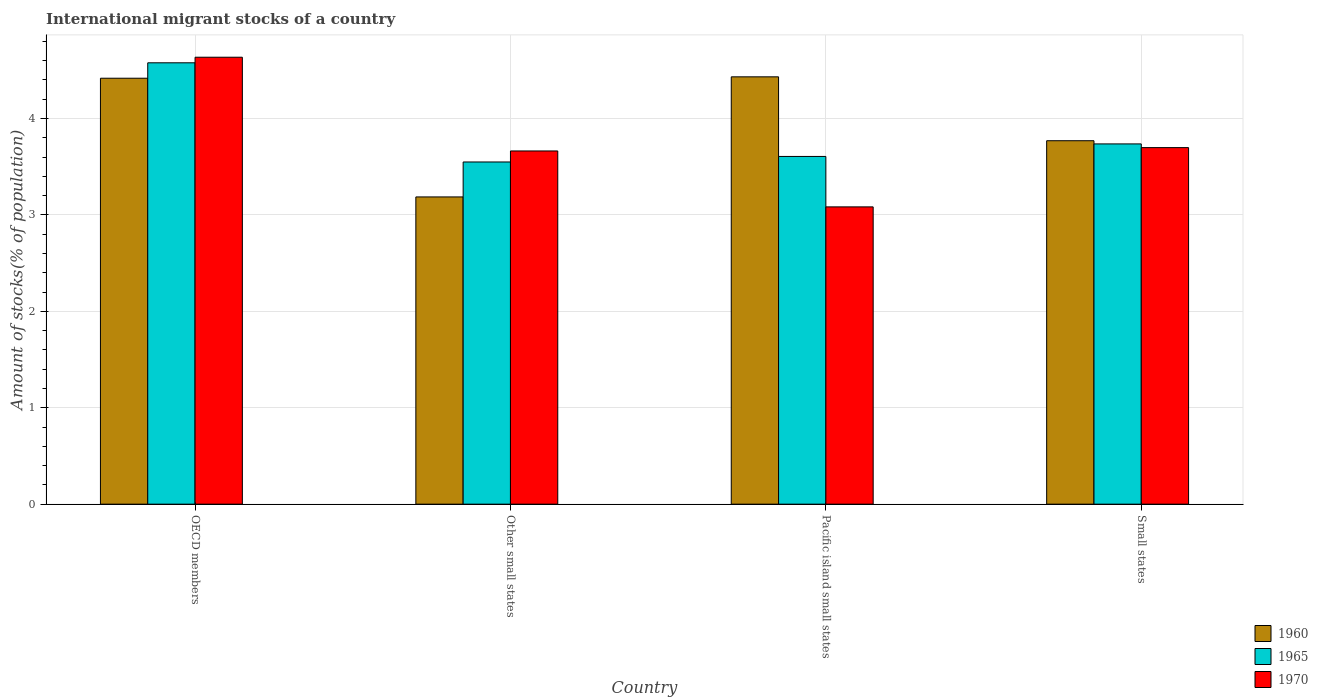Are the number of bars per tick equal to the number of legend labels?
Provide a succinct answer. Yes. Are the number of bars on each tick of the X-axis equal?
Offer a very short reply. Yes. In how many cases, is the number of bars for a given country not equal to the number of legend labels?
Provide a short and direct response. 0. What is the amount of stocks in in 1970 in Small states?
Make the answer very short. 3.7. Across all countries, what is the maximum amount of stocks in in 1965?
Give a very brief answer. 4.58. Across all countries, what is the minimum amount of stocks in in 1965?
Your answer should be very brief. 3.55. In which country was the amount of stocks in in 1960 minimum?
Ensure brevity in your answer.  Other small states. What is the total amount of stocks in in 1965 in the graph?
Give a very brief answer. 15.47. What is the difference between the amount of stocks in in 1970 in OECD members and that in Small states?
Give a very brief answer. 0.94. What is the difference between the amount of stocks in in 1970 in Small states and the amount of stocks in in 1965 in Other small states?
Ensure brevity in your answer.  0.15. What is the average amount of stocks in in 1960 per country?
Provide a short and direct response. 3.95. What is the difference between the amount of stocks in of/in 1965 and amount of stocks in of/in 1960 in Small states?
Ensure brevity in your answer.  -0.03. What is the ratio of the amount of stocks in in 1970 in Other small states to that in Pacific island small states?
Offer a terse response. 1.19. Is the amount of stocks in in 1970 in Other small states less than that in Pacific island small states?
Ensure brevity in your answer.  No. Is the difference between the amount of stocks in in 1965 in Other small states and Small states greater than the difference between the amount of stocks in in 1960 in Other small states and Small states?
Your answer should be compact. Yes. What is the difference between the highest and the second highest amount of stocks in in 1970?
Make the answer very short. -0.03. What is the difference between the highest and the lowest amount of stocks in in 1965?
Your answer should be very brief. 1.03. What does the 2nd bar from the left in Small states represents?
Give a very brief answer. 1965. What does the 1st bar from the right in Small states represents?
Offer a terse response. 1970. Is it the case that in every country, the sum of the amount of stocks in in 1960 and amount of stocks in in 1970 is greater than the amount of stocks in in 1965?
Provide a succinct answer. Yes. How many bars are there?
Make the answer very short. 12. Are all the bars in the graph horizontal?
Offer a terse response. No. How many countries are there in the graph?
Provide a short and direct response. 4. Does the graph contain any zero values?
Ensure brevity in your answer.  No. Does the graph contain grids?
Keep it short and to the point. Yes. Where does the legend appear in the graph?
Your answer should be very brief. Bottom right. How many legend labels are there?
Provide a succinct answer. 3. How are the legend labels stacked?
Ensure brevity in your answer.  Vertical. What is the title of the graph?
Offer a very short reply. International migrant stocks of a country. Does "1999" appear as one of the legend labels in the graph?
Offer a very short reply. No. What is the label or title of the Y-axis?
Offer a terse response. Amount of stocks(% of population). What is the Amount of stocks(% of population) in 1960 in OECD members?
Provide a short and direct response. 4.42. What is the Amount of stocks(% of population) of 1965 in OECD members?
Make the answer very short. 4.58. What is the Amount of stocks(% of population) of 1970 in OECD members?
Ensure brevity in your answer.  4.63. What is the Amount of stocks(% of population) in 1960 in Other small states?
Your response must be concise. 3.19. What is the Amount of stocks(% of population) in 1965 in Other small states?
Provide a short and direct response. 3.55. What is the Amount of stocks(% of population) of 1970 in Other small states?
Offer a very short reply. 3.66. What is the Amount of stocks(% of population) of 1960 in Pacific island small states?
Offer a terse response. 4.43. What is the Amount of stocks(% of population) of 1965 in Pacific island small states?
Ensure brevity in your answer.  3.61. What is the Amount of stocks(% of population) of 1970 in Pacific island small states?
Ensure brevity in your answer.  3.08. What is the Amount of stocks(% of population) in 1960 in Small states?
Your response must be concise. 3.77. What is the Amount of stocks(% of population) in 1965 in Small states?
Make the answer very short. 3.74. What is the Amount of stocks(% of population) of 1970 in Small states?
Make the answer very short. 3.7. Across all countries, what is the maximum Amount of stocks(% of population) in 1960?
Offer a very short reply. 4.43. Across all countries, what is the maximum Amount of stocks(% of population) in 1965?
Provide a short and direct response. 4.58. Across all countries, what is the maximum Amount of stocks(% of population) in 1970?
Offer a terse response. 4.63. Across all countries, what is the minimum Amount of stocks(% of population) of 1960?
Provide a short and direct response. 3.19. Across all countries, what is the minimum Amount of stocks(% of population) of 1965?
Provide a short and direct response. 3.55. Across all countries, what is the minimum Amount of stocks(% of population) in 1970?
Your answer should be compact. 3.08. What is the total Amount of stocks(% of population) in 1960 in the graph?
Your answer should be compact. 15.8. What is the total Amount of stocks(% of population) in 1965 in the graph?
Make the answer very short. 15.47. What is the total Amount of stocks(% of population) in 1970 in the graph?
Provide a short and direct response. 15.08. What is the difference between the Amount of stocks(% of population) of 1960 in OECD members and that in Other small states?
Offer a very short reply. 1.23. What is the difference between the Amount of stocks(% of population) of 1965 in OECD members and that in Other small states?
Your answer should be compact. 1.03. What is the difference between the Amount of stocks(% of population) of 1970 in OECD members and that in Other small states?
Keep it short and to the point. 0.97. What is the difference between the Amount of stocks(% of population) in 1960 in OECD members and that in Pacific island small states?
Give a very brief answer. -0.01. What is the difference between the Amount of stocks(% of population) in 1970 in OECD members and that in Pacific island small states?
Your answer should be compact. 1.55. What is the difference between the Amount of stocks(% of population) of 1960 in OECD members and that in Small states?
Your answer should be compact. 0.65. What is the difference between the Amount of stocks(% of population) of 1965 in OECD members and that in Small states?
Your response must be concise. 0.84. What is the difference between the Amount of stocks(% of population) in 1970 in OECD members and that in Small states?
Keep it short and to the point. 0.94. What is the difference between the Amount of stocks(% of population) in 1960 in Other small states and that in Pacific island small states?
Ensure brevity in your answer.  -1.25. What is the difference between the Amount of stocks(% of population) in 1965 in Other small states and that in Pacific island small states?
Ensure brevity in your answer.  -0.06. What is the difference between the Amount of stocks(% of population) in 1970 in Other small states and that in Pacific island small states?
Your response must be concise. 0.58. What is the difference between the Amount of stocks(% of population) of 1960 in Other small states and that in Small states?
Offer a very short reply. -0.58. What is the difference between the Amount of stocks(% of population) in 1965 in Other small states and that in Small states?
Your answer should be compact. -0.19. What is the difference between the Amount of stocks(% of population) of 1970 in Other small states and that in Small states?
Offer a terse response. -0.03. What is the difference between the Amount of stocks(% of population) in 1960 in Pacific island small states and that in Small states?
Give a very brief answer. 0.66. What is the difference between the Amount of stocks(% of population) of 1965 in Pacific island small states and that in Small states?
Your answer should be very brief. -0.13. What is the difference between the Amount of stocks(% of population) in 1970 in Pacific island small states and that in Small states?
Keep it short and to the point. -0.61. What is the difference between the Amount of stocks(% of population) in 1960 in OECD members and the Amount of stocks(% of population) in 1965 in Other small states?
Ensure brevity in your answer.  0.87. What is the difference between the Amount of stocks(% of population) in 1960 in OECD members and the Amount of stocks(% of population) in 1970 in Other small states?
Give a very brief answer. 0.75. What is the difference between the Amount of stocks(% of population) of 1965 in OECD members and the Amount of stocks(% of population) of 1970 in Other small states?
Your response must be concise. 0.91. What is the difference between the Amount of stocks(% of population) of 1960 in OECD members and the Amount of stocks(% of population) of 1965 in Pacific island small states?
Ensure brevity in your answer.  0.81. What is the difference between the Amount of stocks(% of population) of 1960 in OECD members and the Amount of stocks(% of population) of 1970 in Pacific island small states?
Provide a short and direct response. 1.33. What is the difference between the Amount of stocks(% of population) in 1965 in OECD members and the Amount of stocks(% of population) in 1970 in Pacific island small states?
Ensure brevity in your answer.  1.49. What is the difference between the Amount of stocks(% of population) of 1960 in OECD members and the Amount of stocks(% of population) of 1965 in Small states?
Your answer should be compact. 0.68. What is the difference between the Amount of stocks(% of population) of 1960 in OECD members and the Amount of stocks(% of population) of 1970 in Small states?
Ensure brevity in your answer.  0.72. What is the difference between the Amount of stocks(% of population) of 1965 in OECD members and the Amount of stocks(% of population) of 1970 in Small states?
Offer a very short reply. 0.88. What is the difference between the Amount of stocks(% of population) in 1960 in Other small states and the Amount of stocks(% of population) in 1965 in Pacific island small states?
Keep it short and to the point. -0.42. What is the difference between the Amount of stocks(% of population) in 1960 in Other small states and the Amount of stocks(% of population) in 1970 in Pacific island small states?
Give a very brief answer. 0.1. What is the difference between the Amount of stocks(% of population) of 1965 in Other small states and the Amount of stocks(% of population) of 1970 in Pacific island small states?
Provide a succinct answer. 0.47. What is the difference between the Amount of stocks(% of population) of 1960 in Other small states and the Amount of stocks(% of population) of 1965 in Small states?
Your answer should be very brief. -0.55. What is the difference between the Amount of stocks(% of population) of 1960 in Other small states and the Amount of stocks(% of population) of 1970 in Small states?
Offer a terse response. -0.51. What is the difference between the Amount of stocks(% of population) in 1965 in Other small states and the Amount of stocks(% of population) in 1970 in Small states?
Your answer should be very brief. -0.15. What is the difference between the Amount of stocks(% of population) of 1960 in Pacific island small states and the Amount of stocks(% of population) of 1965 in Small states?
Your answer should be compact. 0.7. What is the difference between the Amount of stocks(% of population) of 1960 in Pacific island small states and the Amount of stocks(% of population) of 1970 in Small states?
Ensure brevity in your answer.  0.73. What is the difference between the Amount of stocks(% of population) of 1965 in Pacific island small states and the Amount of stocks(% of population) of 1970 in Small states?
Offer a very short reply. -0.09. What is the average Amount of stocks(% of population) of 1960 per country?
Ensure brevity in your answer.  3.95. What is the average Amount of stocks(% of population) in 1965 per country?
Keep it short and to the point. 3.87. What is the average Amount of stocks(% of population) in 1970 per country?
Provide a short and direct response. 3.77. What is the difference between the Amount of stocks(% of population) of 1960 and Amount of stocks(% of population) of 1965 in OECD members?
Make the answer very short. -0.16. What is the difference between the Amount of stocks(% of population) in 1960 and Amount of stocks(% of population) in 1970 in OECD members?
Your response must be concise. -0.22. What is the difference between the Amount of stocks(% of population) in 1965 and Amount of stocks(% of population) in 1970 in OECD members?
Ensure brevity in your answer.  -0.06. What is the difference between the Amount of stocks(% of population) in 1960 and Amount of stocks(% of population) in 1965 in Other small states?
Make the answer very short. -0.36. What is the difference between the Amount of stocks(% of population) of 1960 and Amount of stocks(% of population) of 1970 in Other small states?
Provide a succinct answer. -0.48. What is the difference between the Amount of stocks(% of population) in 1965 and Amount of stocks(% of population) in 1970 in Other small states?
Provide a short and direct response. -0.11. What is the difference between the Amount of stocks(% of population) of 1960 and Amount of stocks(% of population) of 1965 in Pacific island small states?
Give a very brief answer. 0.83. What is the difference between the Amount of stocks(% of population) of 1960 and Amount of stocks(% of population) of 1970 in Pacific island small states?
Offer a very short reply. 1.35. What is the difference between the Amount of stocks(% of population) of 1965 and Amount of stocks(% of population) of 1970 in Pacific island small states?
Keep it short and to the point. 0.52. What is the difference between the Amount of stocks(% of population) in 1960 and Amount of stocks(% of population) in 1965 in Small states?
Your answer should be very brief. 0.03. What is the difference between the Amount of stocks(% of population) in 1960 and Amount of stocks(% of population) in 1970 in Small states?
Give a very brief answer. 0.07. What is the difference between the Amount of stocks(% of population) in 1965 and Amount of stocks(% of population) in 1970 in Small states?
Offer a terse response. 0.04. What is the ratio of the Amount of stocks(% of population) of 1960 in OECD members to that in Other small states?
Provide a short and direct response. 1.39. What is the ratio of the Amount of stocks(% of population) of 1965 in OECD members to that in Other small states?
Your answer should be very brief. 1.29. What is the ratio of the Amount of stocks(% of population) of 1970 in OECD members to that in Other small states?
Your answer should be very brief. 1.27. What is the ratio of the Amount of stocks(% of population) of 1960 in OECD members to that in Pacific island small states?
Your answer should be very brief. 1. What is the ratio of the Amount of stocks(% of population) of 1965 in OECD members to that in Pacific island small states?
Your answer should be compact. 1.27. What is the ratio of the Amount of stocks(% of population) of 1970 in OECD members to that in Pacific island small states?
Make the answer very short. 1.5. What is the ratio of the Amount of stocks(% of population) in 1960 in OECD members to that in Small states?
Keep it short and to the point. 1.17. What is the ratio of the Amount of stocks(% of population) in 1965 in OECD members to that in Small states?
Your response must be concise. 1.23. What is the ratio of the Amount of stocks(% of population) in 1970 in OECD members to that in Small states?
Ensure brevity in your answer.  1.25. What is the ratio of the Amount of stocks(% of population) in 1960 in Other small states to that in Pacific island small states?
Provide a short and direct response. 0.72. What is the ratio of the Amount of stocks(% of population) in 1965 in Other small states to that in Pacific island small states?
Your answer should be compact. 0.98. What is the ratio of the Amount of stocks(% of population) of 1970 in Other small states to that in Pacific island small states?
Your answer should be very brief. 1.19. What is the ratio of the Amount of stocks(% of population) of 1960 in Other small states to that in Small states?
Your answer should be very brief. 0.85. What is the ratio of the Amount of stocks(% of population) in 1965 in Other small states to that in Small states?
Your answer should be very brief. 0.95. What is the ratio of the Amount of stocks(% of population) of 1970 in Other small states to that in Small states?
Offer a very short reply. 0.99. What is the ratio of the Amount of stocks(% of population) in 1960 in Pacific island small states to that in Small states?
Your response must be concise. 1.18. What is the ratio of the Amount of stocks(% of population) in 1965 in Pacific island small states to that in Small states?
Offer a terse response. 0.97. What is the ratio of the Amount of stocks(% of population) of 1970 in Pacific island small states to that in Small states?
Your answer should be very brief. 0.83. What is the difference between the highest and the second highest Amount of stocks(% of population) of 1960?
Provide a short and direct response. 0.01. What is the difference between the highest and the second highest Amount of stocks(% of population) in 1965?
Provide a succinct answer. 0.84. What is the difference between the highest and the second highest Amount of stocks(% of population) in 1970?
Offer a terse response. 0.94. What is the difference between the highest and the lowest Amount of stocks(% of population) in 1960?
Give a very brief answer. 1.25. What is the difference between the highest and the lowest Amount of stocks(% of population) in 1965?
Provide a short and direct response. 1.03. What is the difference between the highest and the lowest Amount of stocks(% of population) of 1970?
Provide a succinct answer. 1.55. 